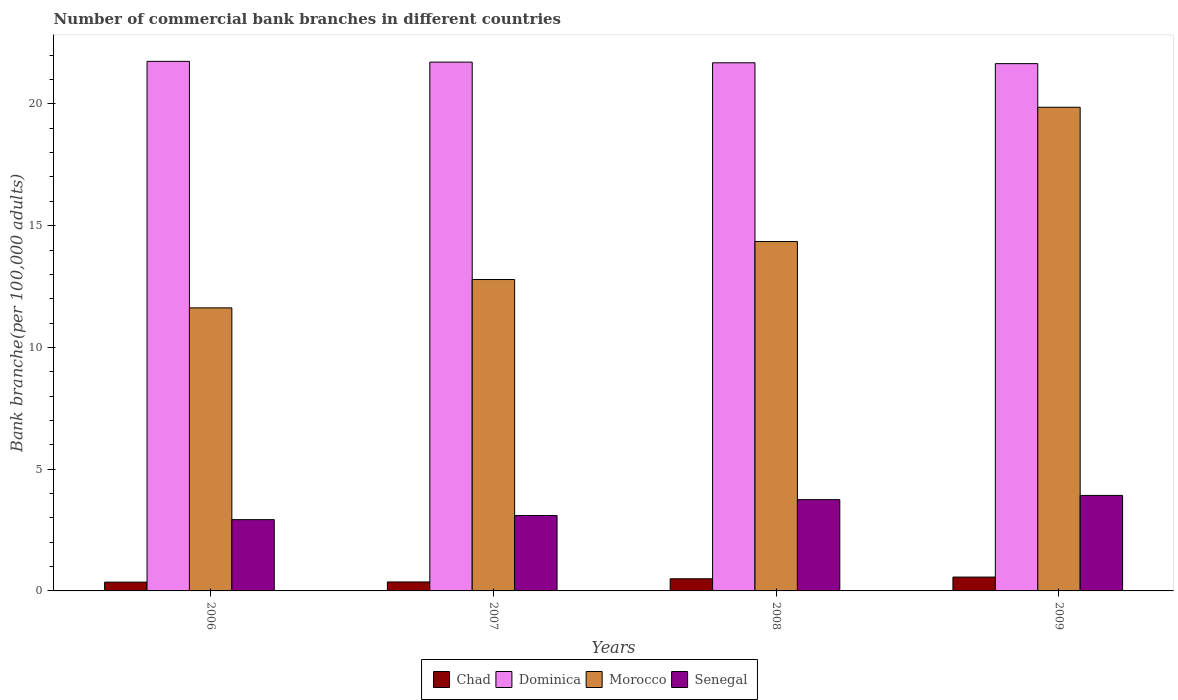How many different coloured bars are there?
Provide a succinct answer. 4. Are the number of bars per tick equal to the number of legend labels?
Give a very brief answer. Yes. How many bars are there on the 2nd tick from the left?
Make the answer very short. 4. How many bars are there on the 3rd tick from the right?
Your answer should be very brief. 4. In how many cases, is the number of bars for a given year not equal to the number of legend labels?
Your answer should be very brief. 0. What is the number of commercial bank branches in Chad in 2007?
Keep it short and to the point. 0.37. Across all years, what is the maximum number of commercial bank branches in Senegal?
Give a very brief answer. 3.92. Across all years, what is the minimum number of commercial bank branches in Morocco?
Your response must be concise. 11.63. In which year was the number of commercial bank branches in Morocco minimum?
Offer a terse response. 2006. What is the total number of commercial bank branches in Morocco in the graph?
Keep it short and to the point. 58.63. What is the difference between the number of commercial bank branches in Chad in 2008 and that in 2009?
Offer a terse response. -0.07. What is the difference between the number of commercial bank branches in Senegal in 2007 and the number of commercial bank branches in Dominica in 2009?
Offer a very short reply. -18.56. What is the average number of commercial bank branches in Dominica per year?
Provide a succinct answer. 21.7. In the year 2008, what is the difference between the number of commercial bank branches in Chad and number of commercial bank branches in Senegal?
Offer a very short reply. -3.25. In how many years, is the number of commercial bank branches in Dominica greater than 15?
Your response must be concise. 4. What is the ratio of the number of commercial bank branches in Senegal in 2006 to that in 2007?
Make the answer very short. 0.95. Is the number of commercial bank branches in Dominica in 2008 less than that in 2009?
Your answer should be very brief. No. What is the difference between the highest and the second highest number of commercial bank branches in Morocco?
Your answer should be compact. 5.51. What is the difference between the highest and the lowest number of commercial bank branches in Dominica?
Provide a short and direct response. 0.09. In how many years, is the number of commercial bank branches in Dominica greater than the average number of commercial bank branches in Dominica taken over all years?
Offer a terse response. 2. What does the 2nd bar from the left in 2009 represents?
Make the answer very short. Dominica. What does the 2nd bar from the right in 2006 represents?
Give a very brief answer. Morocco. How many bars are there?
Your response must be concise. 16. How many years are there in the graph?
Offer a very short reply. 4. Are the values on the major ticks of Y-axis written in scientific E-notation?
Your answer should be very brief. No. Does the graph contain grids?
Ensure brevity in your answer.  No. How many legend labels are there?
Make the answer very short. 4. What is the title of the graph?
Your answer should be very brief. Number of commercial bank branches in different countries. What is the label or title of the X-axis?
Provide a short and direct response. Years. What is the label or title of the Y-axis?
Provide a short and direct response. Bank branche(per 100,0 adults). What is the Bank branche(per 100,000 adults) in Chad in 2006?
Provide a short and direct response. 0.36. What is the Bank branche(per 100,000 adults) of Dominica in 2006?
Your answer should be compact. 21.75. What is the Bank branche(per 100,000 adults) of Morocco in 2006?
Offer a terse response. 11.63. What is the Bank branche(per 100,000 adults) of Senegal in 2006?
Keep it short and to the point. 2.93. What is the Bank branche(per 100,000 adults) of Chad in 2007?
Provide a short and direct response. 0.37. What is the Bank branche(per 100,000 adults) in Dominica in 2007?
Offer a very short reply. 21.72. What is the Bank branche(per 100,000 adults) of Morocco in 2007?
Your response must be concise. 12.79. What is the Bank branche(per 100,000 adults) of Senegal in 2007?
Provide a short and direct response. 3.1. What is the Bank branche(per 100,000 adults) in Chad in 2008?
Provide a succinct answer. 0.5. What is the Bank branche(per 100,000 adults) in Dominica in 2008?
Keep it short and to the point. 21.69. What is the Bank branche(per 100,000 adults) in Morocco in 2008?
Make the answer very short. 14.35. What is the Bank branche(per 100,000 adults) of Senegal in 2008?
Make the answer very short. 3.75. What is the Bank branche(per 100,000 adults) of Chad in 2009?
Your response must be concise. 0.57. What is the Bank branche(per 100,000 adults) in Dominica in 2009?
Your answer should be very brief. 21.66. What is the Bank branche(per 100,000 adults) of Morocco in 2009?
Your answer should be very brief. 19.86. What is the Bank branche(per 100,000 adults) in Senegal in 2009?
Your answer should be very brief. 3.92. Across all years, what is the maximum Bank branche(per 100,000 adults) of Chad?
Your response must be concise. 0.57. Across all years, what is the maximum Bank branche(per 100,000 adults) of Dominica?
Offer a terse response. 21.75. Across all years, what is the maximum Bank branche(per 100,000 adults) of Morocco?
Your answer should be very brief. 19.86. Across all years, what is the maximum Bank branche(per 100,000 adults) of Senegal?
Provide a succinct answer. 3.92. Across all years, what is the minimum Bank branche(per 100,000 adults) of Chad?
Offer a very short reply. 0.36. Across all years, what is the minimum Bank branche(per 100,000 adults) in Dominica?
Your response must be concise. 21.66. Across all years, what is the minimum Bank branche(per 100,000 adults) in Morocco?
Offer a very short reply. 11.63. Across all years, what is the minimum Bank branche(per 100,000 adults) of Senegal?
Keep it short and to the point. 2.93. What is the total Bank branche(per 100,000 adults) of Chad in the graph?
Keep it short and to the point. 1.8. What is the total Bank branche(per 100,000 adults) in Dominica in the graph?
Ensure brevity in your answer.  86.81. What is the total Bank branche(per 100,000 adults) of Morocco in the graph?
Provide a short and direct response. 58.63. What is the total Bank branche(per 100,000 adults) in Senegal in the graph?
Ensure brevity in your answer.  13.7. What is the difference between the Bank branche(per 100,000 adults) in Chad in 2006 and that in 2007?
Provide a short and direct response. -0.01. What is the difference between the Bank branche(per 100,000 adults) in Dominica in 2006 and that in 2007?
Your answer should be very brief. 0.03. What is the difference between the Bank branche(per 100,000 adults) of Morocco in 2006 and that in 2007?
Offer a terse response. -1.16. What is the difference between the Bank branche(per 100,000 adults) in Senegal in 2006 and that in 2007?
Your response must be concise. -0.17. What is the difference between the Bank branche(per 100,000 adults) in Chad in 2006 and that in 2008?
Your answer should be very brief. -0.14. What is the difference between the Bank branche(per 100,000 adults) of Dominica in 2006 and that in 2008?
Keep it short and to the point. 0.06. What is the difference between the Bank branche(per 100,000 adults) in Morocco in 2006 and that in 2008?
Make the answer very short. -2.72. What is the difference between the Bank branche(per 100,000 adults) of Senegal in 2006 and that in 2008?
Your answer should be compact. -0.82. What is the difference between the Bank branche(per 100,000 adults) of Chad in 2006 and that in 2009?
Offer a terse response. -0.21. What is the difference between the Bank branche(per 100,000 adults) of Dominica in 2006 and that in 2009?
Offer a terse response. 0.09. What is the difference between the Bank branche(per 100,000 adults) in Morocco in 2006 and that in 2009?
Provide a short and direct response. -8.24. What is the difference between the Bank branche(per 100,000 adults) in Senegal in 2006 and that in 2009?
Your answer should be very brief. -1. What is the difference between the Bank branche(per 100,000 adults) in Chad in 2007 and that in 2008?
Your answer should be very brief. -0.13. What is the difference between the Bank branche(per 100,000 adults) of Dominica in 2007 and that in 2008?
Make the answer very short. 0.03. What is the difference between the Bank branche(per 100,000 adults) of Morocco in 2007 and that in 2008?
Your answer should be compact. -1.56. What is the difference between the Bank branche(per 100,000 adults) of Senegal in 2007 and that in 2008?
Your answer should be very brief. -0.65. What is the difference between the Bank branche(per 100,000 adults) in Chad in 2007 and that in 2009?
Provide a short and direct response. -0.2. What is the difference between the Bank branche(per 100,000 adults) of Dominica in 2007 and that in 2009?
Offer a terse response. 0.06. What is the difference between the Bank branche(per 100,000 adults) in Morocco in 2007 and that in 2009?
Your answer should be compact. -7.07. What is the difference between the Bank branche(per 100,000 adults) of Senegal in 2007 and that in 2009?
Keep it short and to the point. -0.83. What is the difference between the Bank branche(per 100,000 adults) of Chad in 2008 and that in 2009?
Make the answer very short. -0.07. What is the difference between the Bank branche(per 100,000 adults) of Dominica in 2008 and that in 2009?
Keep it short and to the point. 0.03. What is the difference between the Bank branche(per 100,000 adults) in Morocco in 2008 and that in 2009?
Give a very brief answer. -5.51. What is the difference between the Bank branche(per 100,000 adults) of Senegal in 2008 and that in 2009?
Offer a very short reply. -0.17. What is the difference between the Bank branche(per 100,000 adults) of Chad in 2006 and the Bank branche(per 100,000 adults) of Dominica in 2007?
Provide a short and direct response. -21.36. What is the difference between the Bank branche(per 100,000 adults) in Chad in 2006 and the Bank branche(per 100,000 adults) in Morocco in 2007?
Provide a short and direct response. -12.43. What is the difference between the Bank branche(per 100,000 adults) in Chad in 2006 and the Bank branche(per 100,000 adults) in Senegal in 2007?
Make the answer very short. -2.74. What is the difference between the Bank branche(per 100,000 adults) in Dominica in 2006 and the Bank branche(per 100,000 adults) in Morocco in 2007?
Provide a succinct answer. 8.96. What is the difference between the Bank branche(per 100,000 adults) of Dominica in 2006 and the Bank branche(per 100,000 adults) of Senegal in 2007?
Your answer should be compact. 18.65. What is the difference between the Bank branche(per 100,000 adults) in Morocco in 2006 and the Bank branche(per 100,000 adults) in Senegal in 2007?
Your answer should be compact. 8.53. What is the difference between the Bank branche(per 100,000 adults) in Chad in 2006 and the Bank branche(per 100,000 adults) in Dominica in 2008?
Give a very brief answer. -21.33. What is the difference between the Bank branche(per 100,000 adults) in Chad in 2006 and the Bank branche(per 100,000 adults) in Morocco in 2008?
Provide a short and direct response. -13.99. What is the difference between the Bank branche(per 100,000 adults) in Chad in 2006 and the Bank branche(per 100,000 adults) in Senegal in 2008?
Your answer should be compact. -3.39. What is the difference between the Bank branche(per 100,000 adults) in Dominica in 2006 and the Bank branche(per 100,000 adults) in Morocco in 2008?
Offer a terse response. 7.4. What is the difference between the Bank branche(per 100,000 adults) in Dominica in 2006 and the Bank branche(per 100,000 adults) in Senegal in 2008?
Give a very brief answer. 18. What is the difference between the Bank branche(per 100,000 adults) of Morocco in 2006 and the Bank branche(per 100,000 adults) of Senegal in 2008?
Your response must be concise. 7.88. What is the difference between the Bank branche(per 100,000 adults) of Chad in 2006 and the Bank branche(per 100,000 adults) of Dominica in 2009?
Give a very brief answer. -21.29. What is the difference between the Bank branche(per 100,000 adults) in Chad in 2006 and the Bank branche(per 100,000 adults) in Morocco in 2009?
Provide a short and direct response. -19.5. What is the difference between the Bank branche(per 100,000 adults) in Chad in 2006 and the Bank branche(per 100,000 adults) in Senegal in 2009?
Ensure brevity in your answer.  -3.56. What is the difference between the Bank branche(per 100,000 adults) of Dominica in 2006 and the Bank branche(per 100,000 adults) of Morocco in 2009?
Ensure brevity in your answer.  1.89. What is the difference between the Bank branche(per 100,000 adults) in Dominica in 2006 and the Bank branche(per 100,000 adults) in Senegal in 2009?
Give a very brief answer. 17.83. What is the difference between the Bank branche(per 100,000 adults) in Morocco in 2006 and the Bank branche(per 100,000 adults) in Senegal in 2009?
Your answer should be compact. 7.7. What is the difference between the Bank branche(per 100,000 adults) in Chad in 2007 and the Bank branche(per 100,000 adults) in Dominica in 2008?
Your answer should be very brief. -21.32. What is the difference between the Bank branche(per 100,000 adults) in Chad in 2007 and the Bank branche(per 100,000 adults) in Morocco in 2008?
Give a very brief answer. -13.98. What is the difference between the Bank branche(per 100,000 adults) of Chad in 2007 and the Bank branche(per 100,000 adults) of Senegal in 2008?
Provide a succinct answer. -3.38. What is the difference between the Bank branche(per 100,000 adults) in Dominica in 2007 and the Bank branche(per 100,000 adults) in Morocco in 2008?
Offer a very short reply. 7.37. What is the difference between the Bank branche(per 100,000 adults) in Dominica in 2007 and the Bank branche(per 100,000 adults) in Senegal in 2008?
Keep it short and to the point. 17.97. What is the difference between the Bank branche(per 100,000 adults) of Morocco in 2007 and the Bank branche(per 100,000 adults) of Senegal in 2008?
Give a very brief answer. 9.04. What is the difference between the Bank branche(per 100,000 adults) of Chad in 2007 and the Bank branche(per 100,000 adults) of Dominica in 2009?
Give a very brief answer. -21.29. What is the difference between the Bank branche(per 100,000 adults) of Chad in 2007 and the Bank branche(per 100,000 adults) of Morocco in 2009?
Offer a very short reply. -19.5. What is the difference between the Bank branche(per 100,000 adults) in Chad in 2007 and the Bank branche(per 100,000 adults) in Senegal in 2009?
Make the answer very short. -3.55. What is the difference between the Bank branche(per 100,000 adults) of Dominica in 2007 and the Bank branche(per 100,000 adults) of Morocco in 2009?
Make the answer very short. 1.85. What is the difference between the Bank branche(per 100,000 adults) of Dominica in 2007 and the Bank branche(per 100,000 adults) of Senegal in 2009?
Your response must be concise. 17.79. What is the difference between the Bank branche(per 100,000 adults) in Morocco in 2007 and the Bank branche(per 100,000 adults) in Senegal in 2009?
Offer a terse response. 8.87. What is the difference between the Bank branche(per 100,000 adults) in Chad in 2008 and the Bank branche(per 100,000 adults) in Dominica in 2009?
Your answer should be very brief. -21.16. What is the difference between the Bank branche(per 100,000 adults) in Chad in 2008 and the Bank branche(per 100,000 adults) in Morocco in 2009?
Give a very brief answer. -19.37. What is the difference between the Bank branche(per 100,000 adults) of Chad in 2008 and the Bank branche(per 100,000 adults) of Senegal in 2009?
Your answer should be compact. -3.42. What is the difference between the Bank branche(per 100,000 adults) of Dominica in 2008 and the Bank branche(per 100,000 adults) of Morocco in 2009?
Your answer should be very brief. 1.83. What is the difference between the Bank branche(per 100,000 adults) in Dominica in 2008 and the Bank branche(per 100,000 adults) in Senegal in 2009?
Make the answer very short. 17.77. What is the difference between the Bank branche(per 100,000 adults) of Morocco in 2008 and the Bank branche(per 100,000 adults) of Senegal in 2009?
Your response must be concise. 10.43. What is the average Bank branche(per 100,000 adults) of Chad per year?
Provide a short and direct response. 0.45. What is the average Bank branche(per 100,000 adults) in Dominica per year?
Provide a short and direct response. 21.7. What is the average Bank branche(per 100,000 adults) in Morocco per year?
Give a very brief answer. 14.66. What is the average Bank branche(per 100,000 adults) in Senegal per year?
Provide a short and direct response. 3.42. In the year 2006, what is the difference between the Bank branche(per 100,000 adults) in Chad and Bank branche(per 100,000 adults) in Dominica?
Provide a short and direct response. -21.39. In the year 2006, what is the difference between the Bank branche(per 100,000 adults) in Chad and Bank branche(per 100,000 adults) in Morocco?
Provide a succinct answer. -11.26. In the year 2006, what is the difference between the Bank branche(per 100,000 adults) of Chad and Bank branche(per 100,000 adults) of Senegal?
Your answer should be very brief. -2.57. In the year 2006, what is the difference between the Bank branche(per 100,000 adults) of Dominica and Bank branche(per 100,000 adults) of Morocco?
Offer a very short reply. 10.12. In the year 2006, what is the difference between the Bank branche(per 100,000 adults) of Dominica and Bank branche(per 100,000 adults) of Senegal?
Your response must be concise. 18.82. In the year 2006, what is the difference between the Bank branche(per 100,000 adults) in Morocco and Bank branche(per 100,000 adults) in Senegal?
Your response must be concise. 8.7. In the year 2007, what is the difference between the Bank branche(per 100,000 adults) in Chad and Bank branche(per 100,000 adults) in Dominica?
Provide a short and direct response. -21.35. In the year 2007, what is the difference between the Bank branche(per 100,000 adults) in Chad and Bank branche(per 100,000 adults) in Morocco?
Your answer should be very brief. -12.42. In the year 2007, what is the difference between the Bank branche(per 100,000 adults) of Chad and Bank branche(per 100,000 adults) of Senegal?
Offer a very short reply. -2.73. In the year 2007, what is the difference between the Bank branche(per 100,000 adults) of Dominica and Bank branche(per 100,000 adults) of Morocco?
Ensure brevity in your answer.  8.93. In the year 2007, what is the difference between the Bank branche(per 100,000 adults) of Dominica and Bank branche(per 100,000 adults) of Senegal?
Offer a terse response. 18.62. In the year 2007, what is the difference between the Bank branche(per 100,000 adults) of Morocco and Bank branche(per 100,000 adults) of Senegal?
Provide a short and direct response. 9.69. In the year 2008, what is the difference between the Bank branche(per 100,000 adults) in Chad and Bank branche(per 100,000 adults) in Dominica?
Your answer should be compact. -21.19. In the year 2008, what is the difference between the Bank branche(per 100,000 adults) of Chad and Bank branche(per 100,000 adults) of Morocco?
Offer a very short reply. -13.85. In the year 2008, what is the difference between the Bank branche(per 100,000 adults) in Chad and Bank branche(per 100,000 adults) in Senegal?
Offer a very short reply. -3.25. In the year 2008, what is the difference between the Bank branche(per 100,000 adults) of Dominica and Bank branche(per 100,000 adults) of Morocco?
Keep it short and to the point. 7.34. In the year 2008, what is the difference between the Bank branche(per 100,000 adults) in Dominica and Bank branche(per 100,000 adults) in Senegal?
Your answer should be compact. 17.94. In the year 2008, what is the difference between the Bank branche(per 100,000 adults) in Morocco and Bank branche(per 100,000 adults) in Senegal?
Give a very brief answer. 10.6. In the year 2009, what is the difference between the Bank branche(per 100,000 adults) of Chad and Bank branche(per 100,000 adults) of Dominica?
Make the answer very short. -21.09. In the year 2009, what is the difference between the Bank branche(per 100,000 adults) of Chad and Bank branche(per 100,000 adults) of Morocco?
Ensure brevity in your answer.  -19.3. In the year 2009, what is the difference between the Bank branche(per 100,000 adults) in Chad and Bank branche(per 100,000 adults) in Senegal?
Keep it short and to the point. -3.35. In the year 2009, what is the difference between the Bank branche(per 100,000 adults) in Dominica and Bank branche(per 100,000 adults) in Morocco?
Your answer should be very brief. 1.79. In the year 2009, what is the difference between the Bank branche(per 100,000 adults) of Dominica and Bank branche(per 100,000 adults) of Senegal?
Ensure brevity in your answer.  17.73. In the year 2009, what is the difference between the Bank branche(per 100,000 adults) in Morocco and Bank branche(per 100,000 adults) in Senegal?
Offer a very short reply. 15.94. What is the ratio of the Bank branche(per 100,000 adults) of Chad in 2006 to that in 2007?
Your answer should be compact. 0.98. What is the ratio of the Bank branche(per 100,000 adults) in Morocco in 2006 to that in 2007?
Give a very brief answer. 0.91. What is the ratio of the Bank branche(per 100,000 adults) of Senegal in 2006 to that in 2007?
Give a very brief answer. 0.95. What is the ratio of the Bank branche(per 100,000 adults) in Chad in 2006 to that in 2008?
Provide a short and direct response. 0.72. What is the ratio of the Bank branche(per 100,000 adults) of Morocco in 2006 to that in 2008?
Offer a very short reply. 0.81. What is the ratio of the Bank branche(per 100,000 adults) of Senegal in 2006 to that in 2008?
Your response must be concise. 0.78. What is the ratio of the Bank branche(per 100,000 adults) in Chad in 2006 to that in 2009?
Keep it short and to the point. 0.64. What is the ratio of the Bank branche(per 100,000 adults) of Dominica in 2006 to that in 2009?
Ensure brevity in your answer.  1. What is the ratio of the Bank branche(per 100,000 adults) in Morocco in 2006 to that in 2009?
Provide a succinct answer. 0.59. What is the ratio of the Bank branche(per 100,000 adults) of Senegal in 2006 to that in 2009?
Provide a short and direct response. 0.75. What is the ratio of the Bank branche(per 100,000 adults) in Chad in 2007 to that in 2008?
Offer a very short reply. 0.74. What is the ratio of the Bank branche(per 100,000 adults) of Morocco in 2007 to that in 2008?
Your answer should be compact. 0.89. What is the ratio of the Bank branche(per 100,000 adults) in Senegal in 2007 to that in 2008?
Your response must be concise. 0.83. What is the ratio of the Bank branche(per 100,000 adults) in Chad in 2007 to that in 2009?
Give a very brief answer. 0.65. What is the ratio of the Bank branche(per 100,000 adults) of Morocco in 2007 to that in 2009?
Offer a terse response. 0.64. What is the ratio of the Bank branche(per 100,000 adults) of Senegal in 2007 to that in 2009?
Your answer should be very brief. 0.79. What is the ratio of the Bank branche(per 100,000 adults) in Chad in 2008 to that in 2009?
Your answer should be compact. 0.88. What is the ratio of the Bank branche(per 100,000 adults) of Dominica in 2008 to that in 2009?
Make the answer very short. 1. What is the ratio of the Bank branche(per 100,000 adults) in Morocco in 2008 to that in 2009?
Your response must be concise. 0.72. What is the ratio of the Bank branche(per 100,000 adults) of Senegal in 2008 to that in 2009?
Offer a very short reply. 0.96. What is the difference between the highest and the second highest Bank branche(per 100,000 adults) of Chad?
Ensure brevity in your answer.  0.07. What is the difference between the highest and the second highest Bank branche(per 100,000 adults) in Dominica?
Your response must be concise. 0.03. What is the difference between the highest and the second highest Bank branche(per 100,000 adults) in Morocco?
Keep it short and to the point. 5.51. What is the difference between the highest and the second highest Bank branche(per 100,000 adults) in Senegal?
Make the answer very short. 0.17. What is the difference between the highest and the lowest Bank branche(per 100,000 adults) in Chad?
Your answer should be compact. 0.21. What is the difference between the highest and the lowest Bank branche(per 100,000 adults) in Dominica?
Ensure brevity in your answer.  0.09. What is the difference between the highest and the lowest Bank branche(per 100,000 adults) of Morocco?
Make the answer very short. 8.24. What is the difference between the highest and the lowest Bank branche(per 100,000 adults) in Senegal?
Give a very brief answer. 1. 